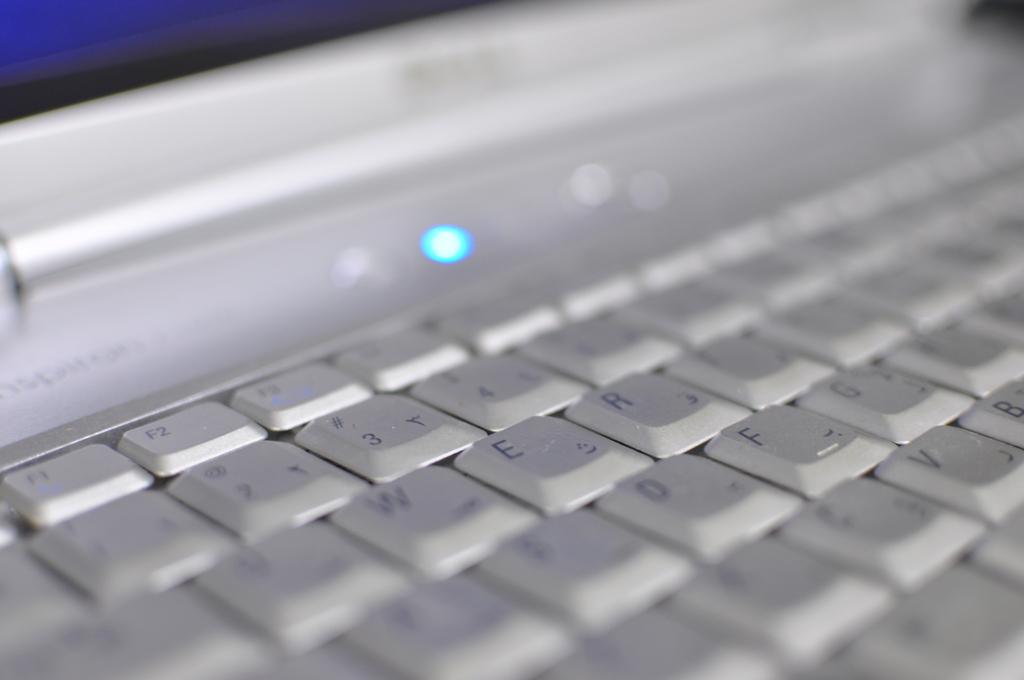What does the first visible key in the top row say?
Provide a succinct answer. F1. What letter is next to the w key?
Provide a succinct answer. E. 